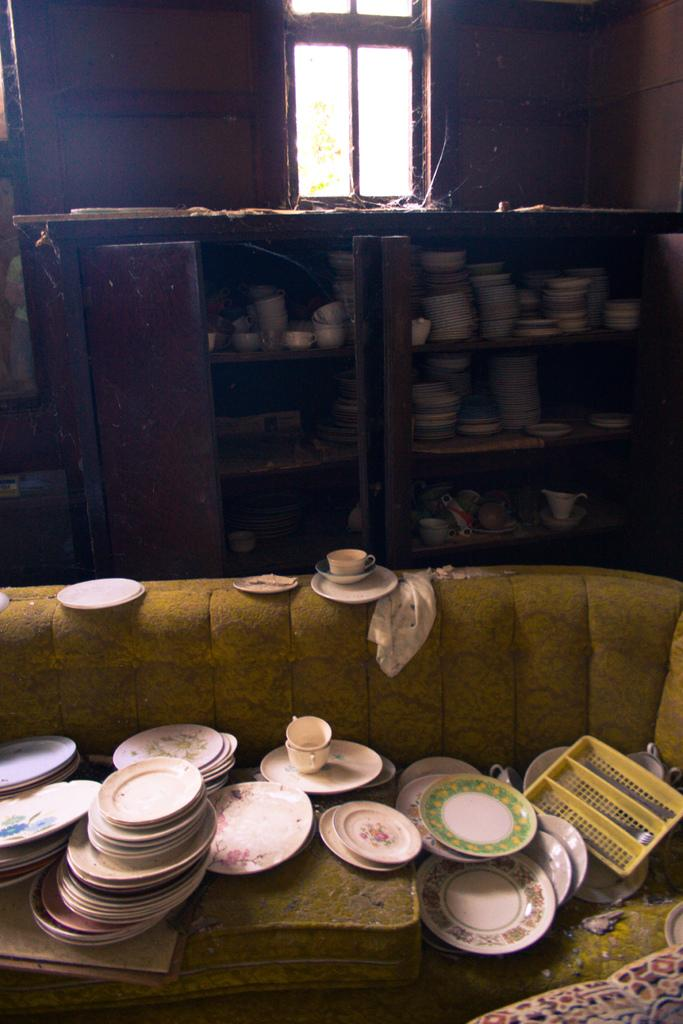What type of furniture is present in the image? There is a sofa in the image. What items are placed on the sofa? Tea cups and saucers are placed on the sofa. What can be seen on the wall in the image? There is a window on the wall in the image. Where can additional tableware be found in the image? There is a rack with bowls and dishes in the image. Can you see any cobwebs in the image? There is no mention of cobwebs in the provided facts, so we cannot determine their presence in the image. What type of authority is depicted in the image? There is no indication of any authority figure or symbol in the image. 